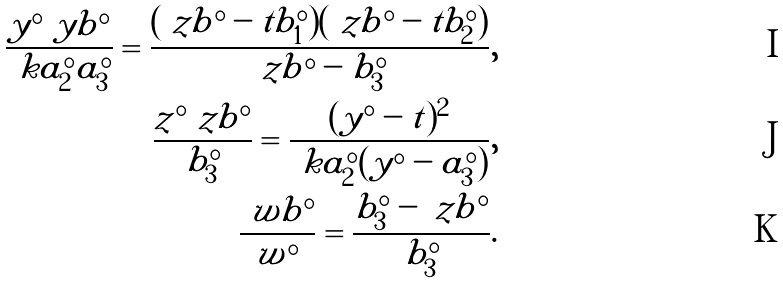Convert formula to latex. <formula><loc_0><loc_0><loc_500><loc_500>\frac { y ^ { \circ } \ y b ^ { \circ } } { \ k a ^ { \circ } _ { 2 } a ^ { \circ } _ { 3 } } = \frac { ( \ z b ^ { \circ } - t b ^ { \circ } _ { 1 } ) ( \ z b ^ { \circ } - t b ^ { \circ } _ { 2 } ) } { \ z b ^ { \circ } - b ^ { \circ } _ { 3 } } , \\ \frac { z ^ { \circ } \ z b ^ { \circ } } { b ^ { \circ } _ { 3 } } = \frac { ( y ^ { \circ } - t ) ^ { 2 } } { \ k a ^ { \circ } _ { 2 } ( y ^ { \circ } - a ^ { \circ } _ { 3 } ) } , \\ \frac { \ w b ^ { \circ } } { w ^ { \circ } } = \frac { b ^ { \circ } _ { 3 } - \ z b ^ { \circ } } { b ^ { \circ } _ { 3 } } .</formula> 